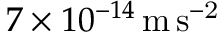Convert formula to latex. <formula><loc_0><loc_0><loc_500><loc_500>7 \times 1 0 ^ { - 1 4 } \, { m \, s ^ { - 2 } }</formula> 